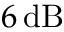Convert formula to latex. <formula><loc_0><loc_0><loc_500><loc_500>6 \, d B</formula> 